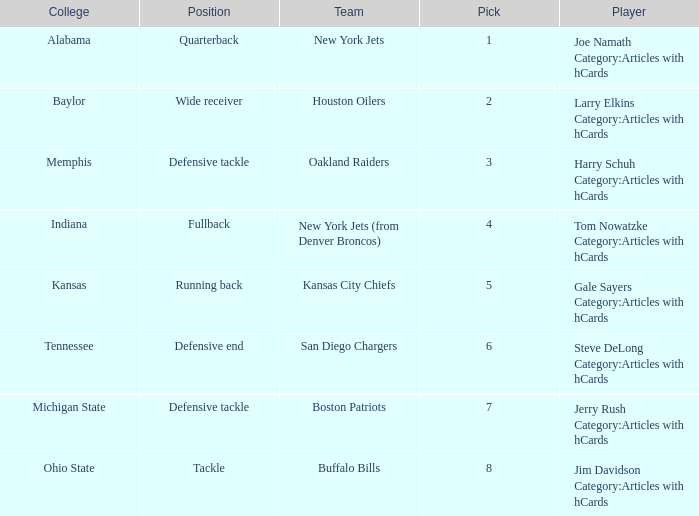Which player is from the College of Alabama? Joe Namath Category:Articles with hCards. 